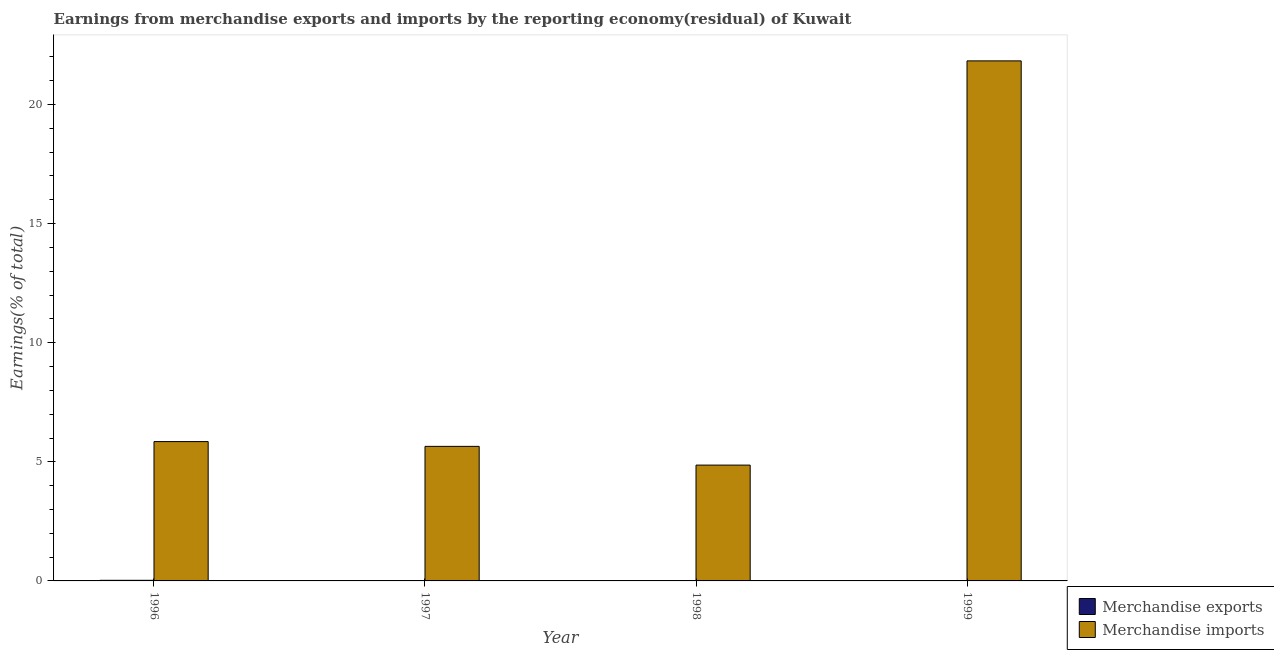Are the number of bars per tick equal to the number of legend labels?
Keep it short and to the point. No. Are the number of bars on each tick of the X-axis equal?
Provide a short and direct response. No. How many bars are there on the 1st tick from the left?
Offer a terse response. 2. In how many cases, is the number of bars for a given year not equal to the number of legend labels?
Your response must be concise. 1. What is the earnings from merchandise exports in 1996?
Your answer should be very brief. 0.03. Across all years, what is the maximum earnings from merchandise imports?
Offer a terse response. 21.83. Across all years, what is the minimum earnings from merchandise imports?
Ensure brevity in your answer.  4.86. In which year was the earnings from merchandise imports maximum?
Provide a succinct answer. 1999. What is the total earnings from merchandise exports in the graph?
Ensure brevity in your answer.  0.03. What is the difference between the earnings from merchandise imports in 1997 and that in 1999?
Offer a terse response. -16.18. What is the difference between the earnings from merchandise imports in 1999 and the earnings from merchandise exports in 1998?
Your answer should be compact. 16.97. What is the average earnings from merchandise exports per year?
Your answer should be compact. 0.01. In how many years, is the earnings from merchandise exports greater than 11 %?
Give a very brief answer. 0. What is the ratio of the earnings from merchandise imports in 1996 to that in 1999?
Your answer should be very brief. 0.27. What is the difference between the highest and the second highest earnings from merchandise imports?
Give a very brief answer. 15.98. What is the difference between the highest and the lowest earnings from merchandise exports?
Give a very brief answer. 0.03. In how many years, is the earnings from merchandise imports greater than the average earnings from merchandise imports taken over all years?
Keep it short and to the point. 1. Is the sum of the earnings from merchandise imports in 1998 and 1999 greater than the maximum earnings from merchandise exports across all years?
Keep it short and to the point. Yes. Are the values on the major ticks of Y-axis written in scientific E-notation?
Your answer should be very brief. No. Does the graph contain grids?
Offer a terse response. No. Where does the legend appear in the graph?
Your answer should be compact. Bottom right. What is the title of the graph?
Give a very brief answer. Earnings from merchandise exports and imports by the reporting economy(residual) of Kuwait. What is the label or title of the Y-axis?
Your answer should be very brief. Earnings(% of total). What is the Earnings(% of total) in Merchandise exports in 1996?
Offer a very short reply. 0.03. What is the Earnings(% of total) of Merchandise imports in 1996?
Ensure brevity in your answer.  5.85. What is the Earnings(% of total) of Merchandise exports in 1997?
Your answer should be very brief. 4.71190732237857e-9. What is the Earnings(% of total) in Merchandise imports in 1997?
Offer a terse response. 5.65. What is the Earnings(% of total) of Merchandise imports in 1998?
Your answer should be very brief. 4.86. What is the Earnings(% of total) of Merchandise exports in 1999?
Your answer should be very brief. 8.65463818696643e-9. What is the Earnings(% of total) of Merchandise imports in 1999?
Your response must be concise. 21.83. Across all years, what is the maximum Earnings(% of total) in Merchandise exports?
Provide a short and direct response. 0.03. Across all years, what is the maximum Earnings(% of total) of Merchandise imports?
Provide a succinct answer. 21.83. Across all years, what is the minimum Earnings(% of total) in Merchandise imports?
Your response must be concise. 4.86. What is the total Earnings(% of total) in Merchandise exports in the graph?
Provide a short and direct response. 0.03. What is the total Earnings(% of total) of Merchandise imports in the graph?
Keep it short and to the point. 38.19. What is the difference between the Earnings(% of total) in Merchandise exports in 1996 and that in 1997?
Ensure brevity in your answer.  0.03. What is the difference between the Earnings(% of total) in Merchandise imports in 1996 and that in 1997?
Provide a succinct answer. 0.2. What is the difference between the Earnings(% of total) of Merchandise imports in 1996 and that in 1998?
Provide a short and direct response. 0.99. What is the difference between the Earnings(% of total) in Merchandise exports in 1996 and that in 1999?
Offer a terse response. 0.03. What is the difference between the Earnings(% of total) in Merchandise imports in 1996 and that in 1999?
Offer a terse response. -15.98. What is the difference between the Earnings(% of total) of Merchandise imports in 1997 and that in 1998?
Your answer should be very brief. 0.79. What is the difference between the Earnings(% of total) of Merchandise imports in 1997 and that in 1999?
Ensure brevity in your answer.  -16.18. What is the difference between the Earnings(% of total) in Merchandise imports in 1998 and that in 1999?
Your response must be concise. -16.97. What is the difference between the Earnings(% of total) of Merchandise exports in 1996 and the Earnings(% of total) of Merchandise imports in 1997?
Provide a succinct answer. -5.62. What is the difference between the Earnings(% of total) in Merchandise exports in 1996 and the Earnings(% of total) in Merchandise imports in 1998?
Offer a terse response. -4.84. What is the difference between the Earnings(% of total) in Merchandise exports in 1996 and the Earnings(% of total) in Merchandise imports in 1999?
Make the answer very short. -21.81. What is the difference between the Earnings(% of total) of Merchandise exports in 1997 and the Earnings(% of total) of Merchandise imports in 1998?
Offer a terse response. -4.86. What is the difference between the Earnings(% of total) of Merchandise exports in 1997 and the Earnings(% of total) of Merchandise imports in 1999?
Your response must be concise. -21.83. What is the average Earnings(% of total) of Merchandise exports per year?
Your response must be concise. 0.01. What is the average Earnings(% of total) in Merchandise imports per year?
Ensure brevity in your answer.  9.55. In the year 1996, what is the difference between the Earnings(% of total) of Merchandise exports and Earnings(% of total) of Merchandise imports?
Provide a succinct answer. -5.82. In the year 1997, what is the difference between the Earnings(% of total) in Merchandise exports and Earnings(% of total) in Merchandise imports?
Provide a succinct answer. -5.65. In the year 1999, what is the difference between the Earnings(% of total) of Merchandise exports and Earnings(% of total) of Merchandise imports?
Offer a very short reply. -21.83. What is the ratio of the Earnings(% of total) of Merchandise exports in 1996 to that in 1997?
Your response must be concise. 5.53e+06. What is the ratio of the Earnings(% of total) of Merchandise imports in 1996 to that in 1997?
Ensure brevity in your answer.  1.04. What is the ratio of the Earnings(% of total) in Merchandise imports in 1996 to that in 1998?
Your answer should be very brief. 1.2. What is the ratio of the Earnings(% of total) in Merchandise exports in 1996 to that in 1999?
Provide a succinct answer. 3.01e+06. What is the ratio of the Earnings(% of total) of Merchandise imports in 1996 to that in 1999?
Offer a very short reply. 0.27. What is the ratio of the Earnings(% of total) in Merchandise imports in 1997 to that in 1998?
Provide a short and direct response. 1.16. What is the ratio of the Earnings(% of total) of Merchandise exports in 1997 to that in 1999?
Provide a short and direct response. 0.54. What is the ratio of the Earnings(% of total) of Merchandise imports in 1997 to that in 1999?
Your answer should be very brief. 0.26. What is the ratio of the Earnings(% of total) in Merchandise imports in 1998 to that in 1999?
Give a very brief answer. 0.22. What is the difference between the highest and the second highest Earnings(% of total) of Merchandise exports?
Keep it short and to the point. 0.03. What is the difference between the highest and the second highest Earnings(% of total) of Merchandise imports?
Provide a succinct answer. 15.98. What is the difference between the highest and the lowest Earnings(% of total) in Merchandise exports?
Your response must be concise. 0.03. What is the difference between the highest and the lowest Earnings(% of total) of Merchandise imports?
Provide a succinct answer. 16.97. 